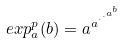Convert formula to latex. <formula><loc_0><loc_0><loc_500><loc_500>e x p _ { a } ^ { p } ( b ) = a ^ { a ^ { \cdot ^ { \cdot ^ { a ^ { b } } } } }</formula> 